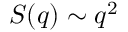Convert formula to latex. <formula><loc_0><loc_0><loc_500><loc_500>S ( q ) \sim q ^ { 2 }</formula> 